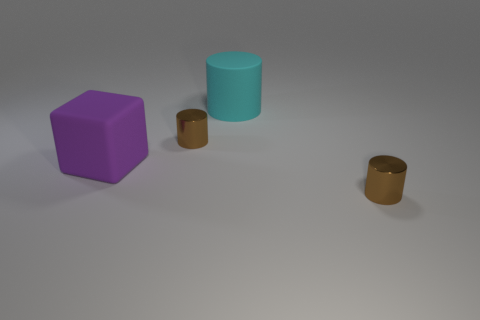How big is the brown thing right of the matte cylinder?
Keep it short and to the point. Small. How many objects are both in front of the big cyan thing and right of the big rubber cube?
Your answer should be very brief. 2. What material is the tiny object that is to the left of the small brown thing right of the large cyan cylinder?
Your answer should be compact. Metal. Are there any big metallic blocks?
Your answer should be compact. No. What shape is the large object that is made of the same material as the cyan cylinder?
Provide a short and direct response. Cube. What is the material of the tiny brown object in front of the purple thing?
Provide a succinct answer. Metal. Is the color of the matte thing that is in front of the large matte cylinder the same as the matte cylinder?
Offer a terse response. No. What size is the cyan cylinder behind the big block on the left side of the big cylinder?
Offer a terse response. Large. Is the number of small brown shiny objects that are right of the cyan rubber thing greater than the number of brown metal cylinders?
Give a very brief answer. No. Does the cyan matte thing behind the purple rubber thing have the same size as the block?
Ensure brevity in your answer.  Yes. 